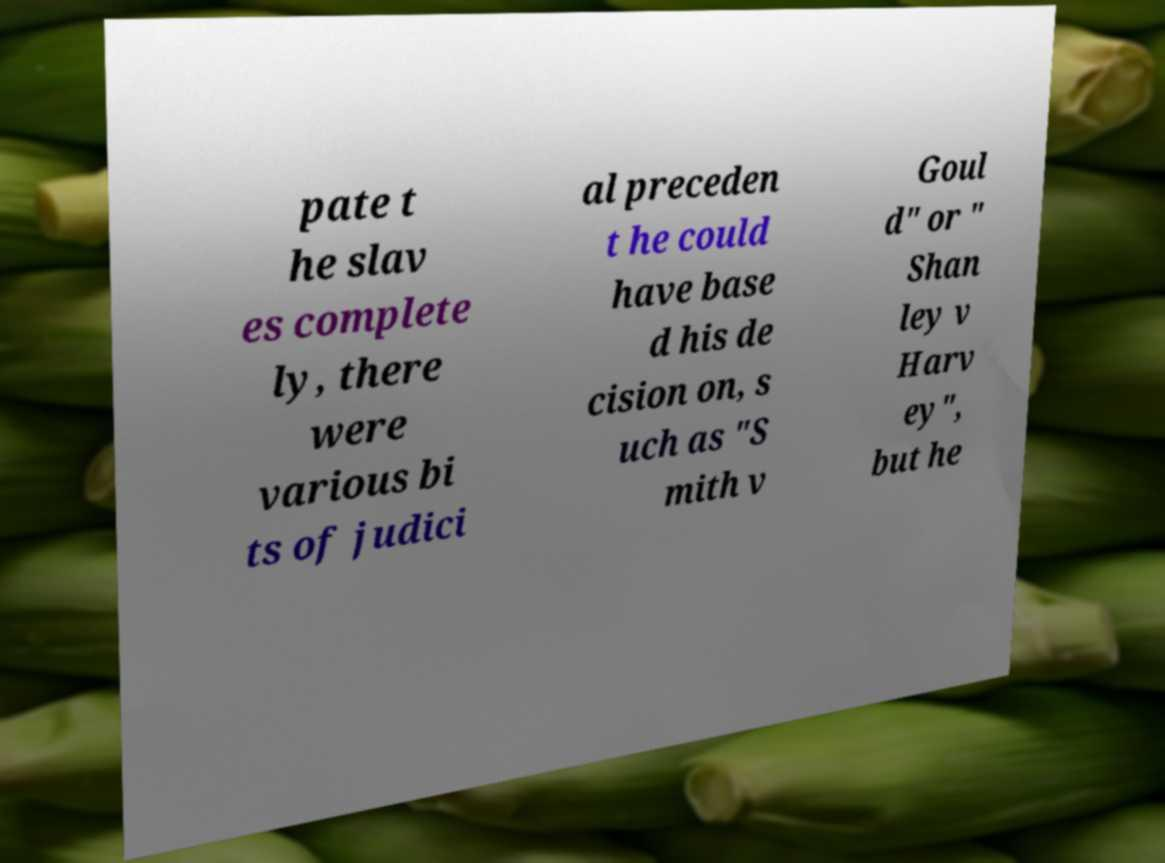For documentation purposes, I need the text within this image transcribed. Could you provide that? pate t he slav es complete ly, there were various bi ts of judici al preceden t he could have base d his de cision on, s uch as "S mith v Goul d" or " Shan ley v Harv ey", but he 